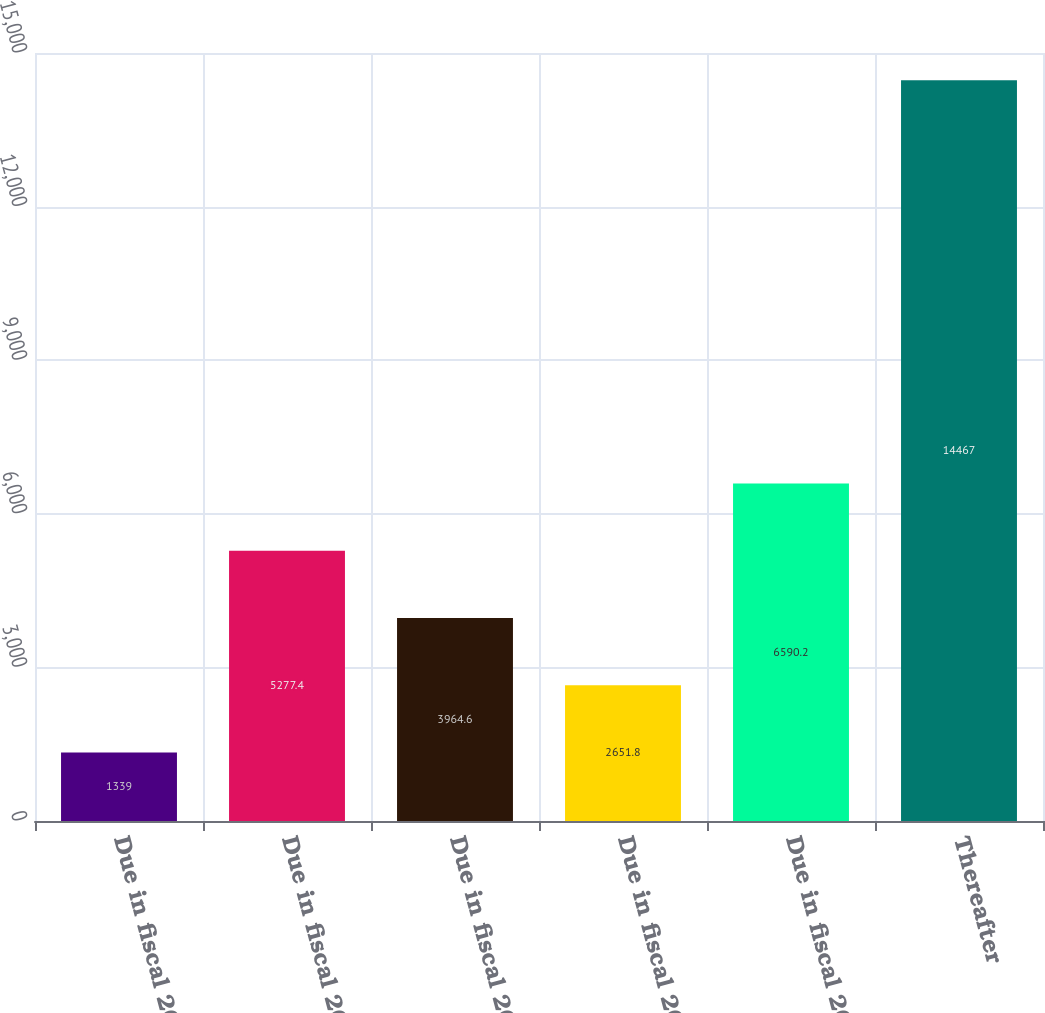Convert chart to OTSL. <chart><loc_0><loc_0><loc_500><loc_500><bar_chart><fcel>Due in fiscal 2008<fcel>Due in fiscal 2009<fcel>Due in fiscal 2010<fcel>Due in fiscal 2011<fcel>Due in fiscal 2012<fcel>Thereafter<nl><fcel>1339<fcel>5277.4<fcel>3964.6<fcel>2651.8<fcel>6590.2<fcel>14467<nl></chart> 